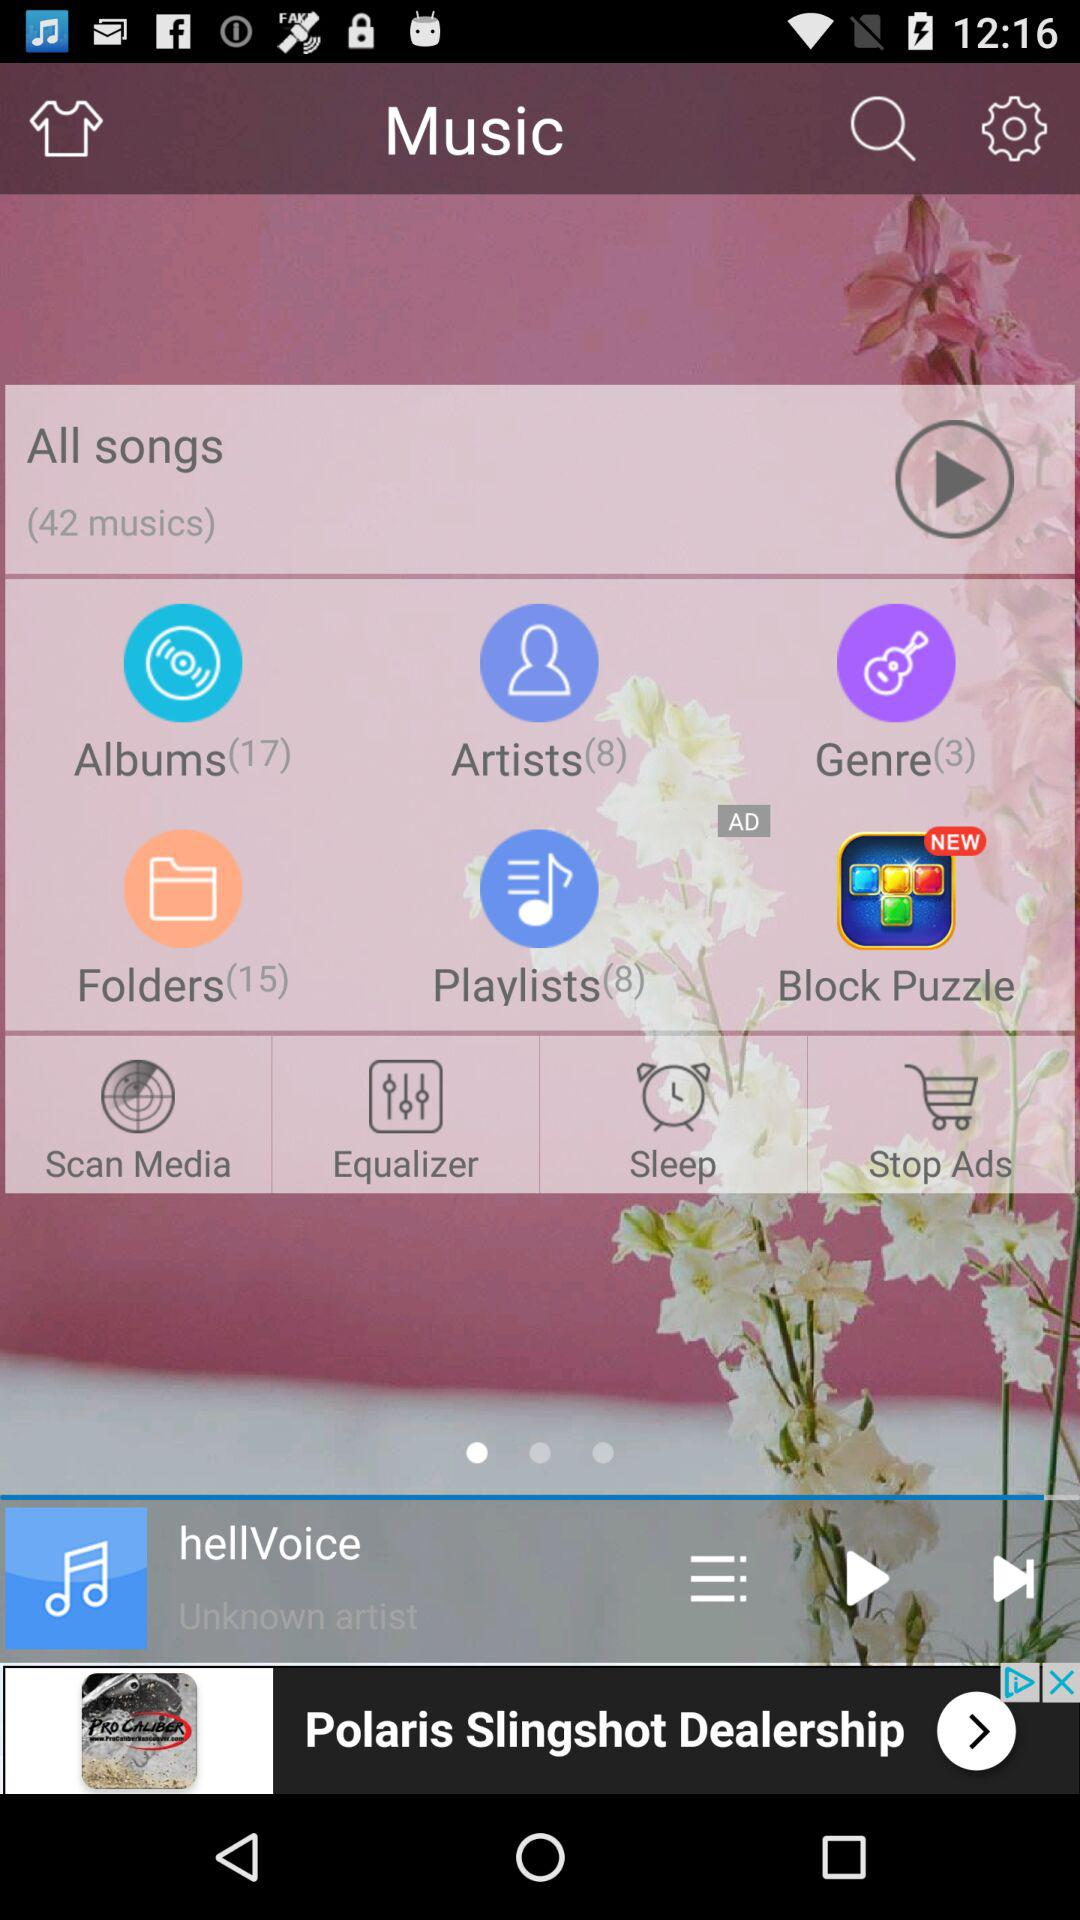How many albums are there? There are 17 albums. 